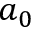<formula> <loc_0><loc_0><loc_500><loc_500>a _ { 0 }</formula> 